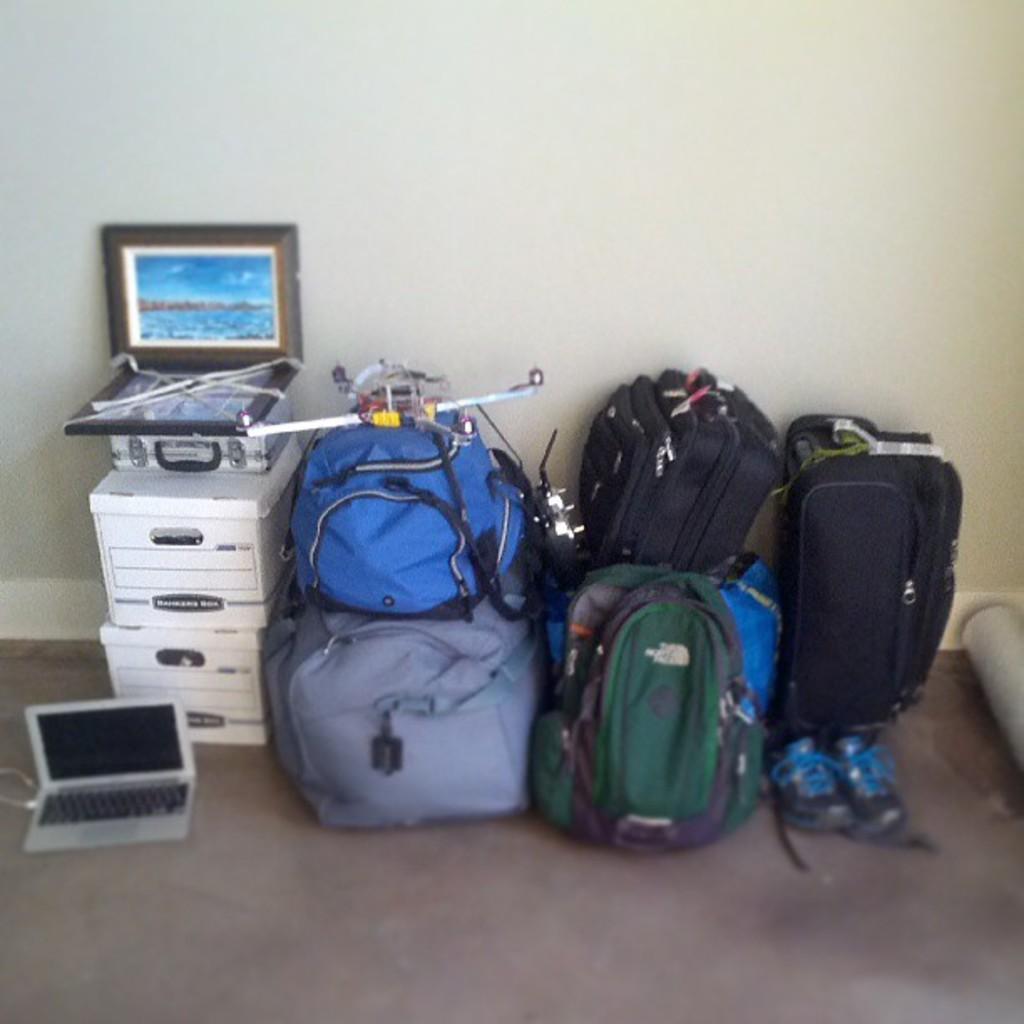How would you summarize this image in a sentence or two? This is the picture inside the room. There are laptop, bags, photo frame and shoes. 